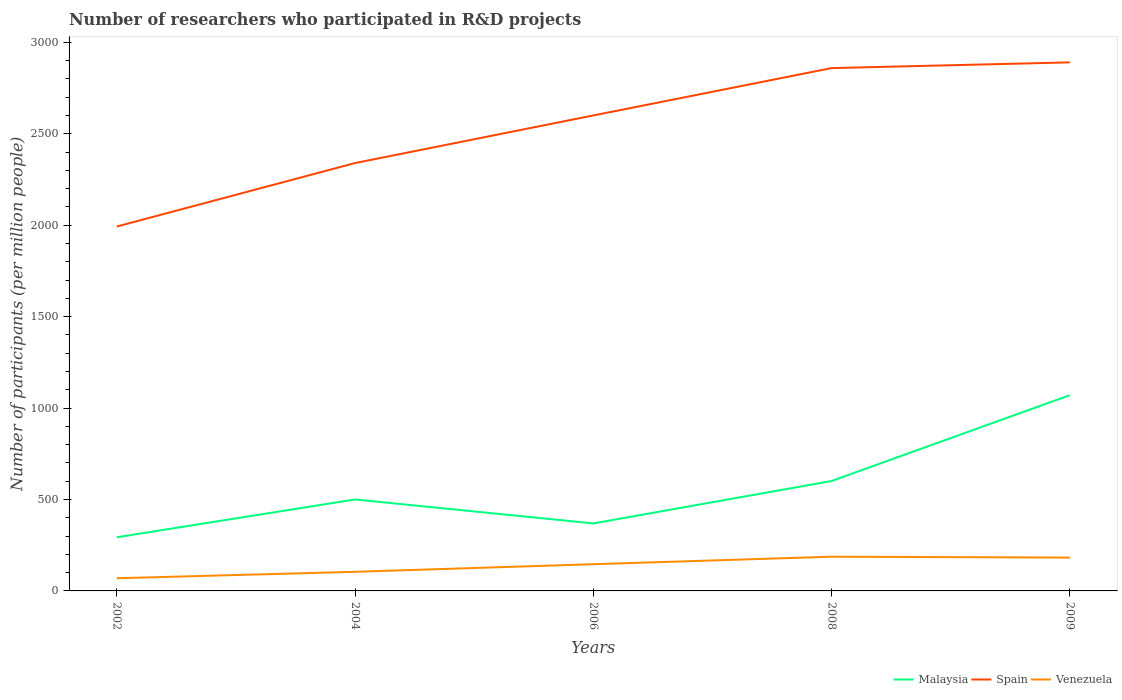Across all years, what is the maximum number of researchers who participated in R&D projects in Venezuela?
Offer a terse response. 69.33. In which year was the number of researchers who participated in R&D projects in Venezuela maximum?
Offer a terse response. 2002. What is the total number of researchers who participated in R&D projects in Malaysia in the graph?
Keep it short and to the point. -570.26. What is the difference between the highest and the second highest number of researchers who participated in R&D projects in Malaysia?
Your answer should be very brief. 777.1. What is the difference between the highest and the lowest number of researchers who participated in R&D projects in Spain?
Offer a very short reply. 3. How many years are there in the graph?
Give a very brief answer. 5. Does the graph contain grids?
Provide a short and direct response. No. How many legend labels are there?
Keep it short and to the point. 3. What is the title of the graph?
Offer a terse response. Number of researchers who participated in R&D projects. Does "Iraq" appear as one of the legend labels in the graph?
Your response must be concise. No. What is the label or title of the Y-axis?
Offer a terse response. Number of participants (per million people). What is the Number of participants (per million people) of Malaysia in 2002?
Provide a succinct answer. 293.3. What is the Number of participants (per million people) in Spain in 2002?
Your answer should be very brief. 1992.51. What is the Number of participants (per million people) in Venezuela in 2002?
Your answer should be very brief. 69.33. What is the Number of participants (per million people) of Malaysia in 2004?
Give a very brief answer. 500.14. What is the Number of participants (per million people) in Spain in 2004?
Provide a short and direct response. 2339.61. What is the Number of participants (per million people) of Venezuela in 2004?
Your answer should be compact. 104.47. What is the Number of participants (per million people) of Malaysia in 2006?
Offer a very short reply. 369.12. What is the Number of participants (per million people) of Spain in 2006?
Provide a short and direct response. 2600. What is the Number of participants (per million people) of Venezuela in 2006?
Offer a terse response. 146.1. What is the Number of participants (per million people) of Malaysia in 2008?
Keep it short and to the point. 600.96. What is the Number of participants (per million people) of Spain in 2008?
Your answer should be compact. 2858.9. What is the Number of participants (per million people) of Venezuela in 2008?
Provide a succinct answer. 187.11. What is the Number of participants (per million people) in Malaysia in 2009?
Make the answer very short. 1070.39. What is the Number of participants (per million people) of Spain in 2009?
Your answer should be compact. 2890.22. What is the Number of participants (per million people) of Venezuela in 2009?
Give a very brief answer. 182.4. Across all years, what is the maximum Number of participants (per million people) of Malaysia?
Ensure brevity in your answer.  1070.39. Across all years, what is the maximum Number of participants (per million people) of Spain?
Offer a very short reply. 2890.22. Across all years, what is the maximum Number of participants (per million people) in Venezuela?
Ensure brevity in your answer.  187.11. Across all years, what is the minimum Number of participants (per million people) of Malaysia?
Your answer should be compact. 293.3. Across all years, what is the minimum Number of participants (per million people) in Spain?
Your answer should be very brief. 1992.51. Across all years, what is the minimum Number of participants (per million people) in Venezuela?
Offer a very short reply. 69.33. What is the total Number of participants (per million people) in Malaysia in the graph?
Your answer should be very brief. 2833.91. What is the total Number of participants (per million people) in Spain in the graph?
Offer a terse response. 1.27e+04. What is the total Number of participants (per million people) of Venezuela in the graph?
Provide a short and direct response. 689.41. What is the difference between the Number of participants (per million people) of Malaysia in 2002 and that in 2004?
Offer a terse response. -206.84. What is the difference between the Number of participants (per million people) of Spain in 2002 and that in 2004?
Offer a terse response. -347.1. What is the difference between the Number of participants (per million people) in Venezuela in 2002 and that in 2004?
Give a very brief answer. -35.13. What is the difference between the Number of participants (per million people) in Malaysia in 2002 and that in 2006?
Give a very brief answer. -75.83. What is the difference between the Number of participants (per million people) in Spain in 2002 and that in 2006?
Keep it short and to the point. -607.48. What is the difference between the Number of participants (per million people) of Venezuela in 2002 and that in 2006?
Provide a short and direct response. -76.77. What is the difference between the Number of participants (per million people) of Malaysia in 2002 and that in 2008?
Provide a short and direct response. -307.66. What is the difference between the Number of participants (per million people) in Spain in 2002 and that in 2008?
Provide a short and direct response. -866.39. What is the difference between the Number of participants (per million people) of Venezuela in 2002 and that in 2008?
Provide a short and direct response. -117.78. What is the difference between the Number of participants (per million people) in Malaysia in 2002 and that in 2009?
Keep it short and to the point. -777.1. What is the difference between the Number of participants (per million people) of Spain in 2002 and that in 2009?
Offer a terse response. -897.71. What is the difference between the Number of participants (per million people) of Venezuela in 2002 and that in 2009?
Offer a very short reply. -113.06. What is the difference between the Number of participants (per million people) of Malaysia in 2004 and that in 2006?
Provide a succinct answer. 131.01. What is the difference between the Number of participants (per million people) of Spain in 2004 and that in 2006?
Ensure brevity in your answer.  -260.39. What is the difference between the Number of participants (per million people) in Venezuela in 2004 and that in 2006?
Your response must be concise. -41.63. What is the difference between the Number of participants (per million people) in Malaysia in 2004 and that in 2008?
Ensure brevity in your answer.  -100.82. What is the difference between the Number of participants (per million people) in Spain in 2004 and that in 2008?
Offer a very short reply. -519.3. What is the difference between the Number of participants (per million people) of Venezuela in 2004 and that in 2008?
Your response must be concise. -82.65. What is the difference between the Number of participants (per million people) of Malaysia in 2004 and that in 2009?
Offer a terse response. -570.26. What is the difference between the Number of participants (per million people) in Spain in 2004 and that in 2009?
Ensure brevity in your answer.  -550.62. What is the difference between the Number of participants (per million people) of Venezuela in 2004 and that in 2009?
Make the answer very short. -77.93. What is the difference between the Number of participants (per million people) in Malaysia in 2006 and that in 2008?
Give a very brief answer. -231.84. What is the difference between the Number of participants (per million people) in Spain in 2006 and that in 2008?
Provide a short and direct response. -258.91. What is the difference between the Number of participants (per million people) of Venezuela in 2006 and that in 2008?
Keep it short and to the point. -41.01. What is the difference between the Number of participants (per million people) of Malaysia in 2006 and that in 2009?
Offer a very short reply. -701.27. What is the difference between the Number of participants (per million people) of Spain in 2006 and that in 2009?
Offer a terse response. -290.23. What is the difference between the Number of participants (per million people) of Venezuela in 2006 and that in 2009?
Provide a short and direct response. -36.3. What is the difference between the Number of participants (per million people) in Malaysia in 2008 and that in 2009?
Keep it short and to the point. -469.43. What is the difference between the Number of participants (per million people) in Spain in 2008 and that in 2009?
Give a very brief answer. -31.32. What is the difference between the Number of participants (per million people) of Venezuela in 2008 and that in 2009?
Provide a succinct answer. 4.72. What is the difference between the Number of participants (per million people) in Malaysia in 2002 and the Number of participants (per million people) in Spain in 2004?
Give a very brief answer. -2046.31. What is the difference between the Number of participants (per million people) in Malaysia in 2002 and the Number of participants (per million people) in Venezuela in 2004?
Provide a succinct answer. 188.83. What is the difference between the Number of participants (per million people) in Spain in 2002 and the Number of participants (per million people) in Venezuela in 2004?
Keep it short and to the point. 1888.04. What is the difference between the Number of participants (per million people) in Malaysia in 2002 and the Number of participants (per million people) in Spain in 2006?
Your answer should be compact. -2306.7. What is the difference between the Number of participants (per million people) in Malaysia in 2002 and the Number of participants (per million people) in Venezuela in 2006?
Make the answer very short. 147.2. What is the difference between the Number of participants (per million people) of Spain in 2002 and the Number of participants (per million people) of Venezuela in 2006?
Offer a terse response. 1846.41. What is the difference between the Number of participants (per million people) in Malaysia in 2002 and the Number of participants (per million people) in Spain in 2008?
Give a very brief answer. -2565.6. What is the difference between the Number of participants (per million people) in Malaysia in 2002 and the Number of participants (per million people) in Venezuela in 2008?
Ensure brevity in your answer.  106.18. What is the difference between the Number of participants (per million people) in Spain in 2002 and the Number of participants (per million people) in Venezuela in 2008?
Keep it short and to the point. 1805.4. What is the difference between the Number of participants (per million people) of Malaysia in 2002 and the Number of participants (per million people) of Spain in 2009?
Ensure brevity in your answer.  -2596.93. What is the difference between the Number of participants (per million people) in Malaysia in 2002 and the Number of participants (per million people) in Venezuela in 2009?
Keep it short and to the point. 110.9. What is the difference between the Number of participants (per million people) of Spain in 2002 and the Number of participants (per million people) of Venezuela in 2009?
Your response must be concise. 1810.11. What is the difference between the Number of participants (per million people) of Malaysia in 2004 and the Number of participants (per million people) of Spain in 2006?
Provide a succinct answer. -2099.86. What is the difference between the Number of participants (per million people) in Malaysia in 2004 and the Number of participants (per million people) in Venezuela in 2006?
Provide a short and direct response. 354.04. What is the difference between the Number of participants (per million people) of Spain in 2004 and the Number of participants (per million people) of Venezuela in 2006?
Provide a short and direct response. 2193.51. What is the difference between the Number of participants (per million people) of Malaysia in 2004 and the Number of participants (per million people) of Spain in 2008?
Ensure brevity in your answer.  -2358.76. What is the difference between the Number of participants (per million people) of Malaysia in 2004 and the Number of participants (per million people) of Venezuela in 2008?
Offer a terse response. 313.02. What is the difference between the Number of participants (per million people) in Spain in 2004 and the Number of participants (per million people) in Venezuela in 2008?
Provide a short and direct response. 2152.49. What is the difference between the Number of participants (per million people) in Malaysia in 2004 and the Number of participants (per million people) in Spain in 2009?
Provide a succinct answer. -2390.08. What is the difference between the Number of participants (per million people) in Malaysia in 2004 and the Number of participants (per million people) in Venezuela in 2009?
Make the answer very short. 317.74. What is the difference between the Number of participants (per million people) of Spain in 2004 and the Number of participants (per million people) of Venezuela in 2009?
Ensure brevity in your answer.  2157.21. What is the difference between the Number of participants (per million people) of Malaysia in 2006 and the Number of participants (per million people) of Spain in 2008?
Give a very brief answer. -2489.78. What is the difference between the Number of participants (per million people) of Malaysia in 2006 and the Number of participants (per million people) of Venezuela in 2008?
Make the answer very short. 182.01. What is the difference between the Number of participants (per million people) in Spain in 2006 and the Number of participants (per million people) in Venezuela in 2008?
Give a very brief answer. 2412.88. What is the difference between the Number of participants (per million people) in Malaysia in 2006 and the Number of participants (per million people) in Spain in 2009?
Offer a very short reply. -2521.1. What is the difference between the Number of participants (per million people) in Malaysia in 2006 and the Number of participants (per million people) in Venezuela in 2009?
Offer a very short reply. 186.73. What is the difference between the Number of participants (per million people) of Spain in 2006 and the Number of participants (per million people) of Venezuela in 2009?
Offer a very short reply. 2417.6. What is the difference between the Number of participants (per million people) of Malaysia in 2008 and the Number of participants (per million people) of Spain in 2009?
Your response must be concise. -2289.26. What is the difference between the Number of participants (per million people) of Malaysia in 2008 and the Number of participants (per million people) of Venezuela in 2009?
Offer a very short reply. 418.56. What is the difference between the Number of participants (per million people) of Spain in 2008 and the Number of participants (per million people) of Venezuela in 2009?
Make the answer very short. 2676.5. What is the average Number of participants (per million people) of Malaysia per year?
Keep it short and to the point. 566.78. What is the average Number of participants (per million people) of Spain per year?
Offer a very short reply. 2536.25. What is the average Number of participants (per million people) in Venezuela per year?
Ensure brevity in your answer.  137.88. In the year 2002, what is the difference between the Number of participants (per million people) of Malaysia and Number of participants (per million people) of Spain?
Make the answer very short. -1699.21. In the year 2002, what is the difference between the Number of participants (per million people) of Malaysia and Number of participants (per million people) of Venezuela?
Give a very brief answer. 223.96. In the year 2002, what is the difference between the Number of participants (per million people) of Spain and Number of participants (per million people) of Venezuela?
Your answer should be very brief. 1923.18. In the year 2004, what is the difference between the Number of participants (per million people) in Malaysia and Number of participants (per million people) in Spain?
Provide a succinct answer. -1839.47. In the year 2004, what is the difference between the Number of participants (per million people) in Malaysia and Number of participants (per million people) in Venezuela?
Your response must be concise. 395.67. In the year 2004, what is the difference between the Number of participants (per million people) of Spain and Number of participants (per million people) of Venezuela?
Ensure brevity in your answer.  2235.14. In the year 2006, what is the difference between the Number of participants (per million people) in Malaysia and Number of participants (per million people) in Spain?
Offer a terse response. -2230.87. In the year 2006, what is the difference between the Number of participants (per million people) in Malaysia and Number of participants (per million people) in Venezuela?
Your answer should be compact. 223.02. In the year 2006, what is the difference between the Number of participants (per million people) in Spain and Number of participants (per million people) in Venezuela?
Provide a short and direct response. 2453.9. In the year 2008, what is the difference between the Number of participants (per million people) of Malaysia and Number of participants (per million people) of Spain?
Your answer should be compact. -2257.94. In the year 2008, what is the difference between the Number of participants (per million people) of Malaysia and Number of participants (per million people) of Venezuela?
Your answer should be very brief. 413.85. In the year 2008, what is the difference between the Number of participants (per million people) of Spain and Number of participants (per million people) of Venezuela?
Offer a very short reply. 2671.79. In the year 2009, what is the difference between the Number of participants (per million people) in Malaysia and Number of participants (per million people) in Spain?
Give a very brief answer. -1819.83. In the year 2009, what is the difference between the Number of participants (per million people) of Malaysia and Number of participants (per million people) of Venezuela?
Offer a terse response. 888. In the year 2009, what is the difference between the Number of participants (per million people) in Spain and Number of participants (per million people) in Venezuela?
Ensure brevity in your answer.  2707.83. What is the ratio of the Number of participants (per million people) in Malaysia in 2002 to that in 2004?
Keep it short and to the point. 0.59. What is the ratio of the Number of participants (per million people) in Spain in 2002 to that in 2004?
Offer a very short reply. 0.85. What is the ratio of the Number of participants (per million people) in Venezuela in 2002 to that in 2004?
Your answer should be compact. 0.66. What is the ratio of the Number of participants (per million people) in Malaysia in 2002 to that in 2006?
Your answer should be compact. 0.79. What is the ratio of the Number of participants (per million people) of Spain in 2002 to that in 2006?
Offer a very short reply. 0.77. What is the ratio of the Number of participants (per million people) of Venezuela in 2002 to that in 2006?
Keep it short and to the point. 0.47. What is the ratio of the Number of participants (per million people) of Malaysia in 2002 to that in 2008?
Offer a terse response. 0.49. What is the ratio of the Number of participants (per million people) in Spain in 2002 to that in 2008?
Offer a terse response. 0.7. What is the ratio of the Number of participants (per million people) of Venezuela in 2002 to that in 2008?
Make the answer very short. 0.37. What is the ratio of the Number of participants (per million people) of Malaysia in 2002 to that in 2009?
Keep it short and to the point. 0.27. What is the ratio of the Number of participants (per million people) of Spain in 2002 to that in 2009?
Give a very brief answer. 0.69. What is the ratio of the Number of participants (per million people) of Venezuela in 2002 to that in 2009?
Provide a succinct answer. 0.38. What is the ratio of the Number of participants (per million people) in Malaysia in 2004 to that in 2006?
Provide a succinct answer. 1.35. What is the ratio of the Number of participants (per million people) of Spain in 2004 to that in 2006?
Give a very brief answer. 0.9. What is the ratio of the Number of participants (per million people) of Venezuela in 2004 to that in 2006?
Make the answer very short. 0.71. What is the ratio of the Number of participants (per million people) in Malaysia in 2004 to that in 2008?
Provide a succinct answer. 0.83. What is the ratio of the Number of participants (per million people) in Spain in 2004 to that in 2008?
Your response must be concise. 0.82. What is the ratio of the Number of participants (per million people) in Venezuela in 2004 to that in 2008?
Ensure brevity in your answer.  0.56. What is the ratio of the Number of participants (per million people) in Malaysia in 2004 to that in 2009?
Ensure brevity in your answer.  0.47. What is the ratio of the Number of participants (per million people) of Spain in 2004 to that in 2009?
Provide a short and direct response. 0.81. What is the ratio of the Number of participants (per million people) in Venezuela in 2004 to that in 2009?
Provide a succinct answer. 0.57. What is the ratio of the Number of participants (per million people) in Malaysia in 2006 to that in 2008?
Give a very brief answer. 0.61. What is the ratio of the Number of participants (per million people) of Spain in 2006 to that in 2008?
Ensure brevity in your answer.  0.91. What is the ratio of the Number of participants (per million people) of Venezuela in 2006 to that in 2008?
Your answer should be very brief. 0.78. What is the ratio of the Number of participants (per million people) of Malaysia in 2006 to that in 2009?
Ensure brevity in your answer.  0.34. What is the ratio of the Number of participants (per million people) in Spain in 2006 to that in 2009?
Your response must be concise. 0.9. What is the ratio of the Number of participants (per million people) of Venezuela in 2006 to that in 2009?
Offer a terse response. 0.8. What is the ratio of the Number of participants (per million people) of Malaysia in 2008 to that in 2009?
Your response must be concise. 0.56. What is the ratio of the Number of participants (per million people) of Venezuela in 2008 to that in 2009?
Provide a short and direct response. 1.03. What is the difference between the highest and the second highest Number of participants (per million people) in Malaysia?
Keep it short and to the point. 469.43. What is the difference between the highest and the second highest Number of participants (per million people) in Spain?
Provide a succinct answer. 31.32. What is the difference between the highest and the second highest Number of participants (per million people) in Venezuela?
Your response must be concise. 4.72. What is the difference between the highest and the lowest Number of participants (per million people) of Malaysia?
Your answer should be very brief. 777.1. What is the difference between the highest and the lowest Number of participants (per million people) in Spain?
Your answer should be compact. 897.71. What is the difference between the highest and the lowest Number of participants (per million people) of Venezuela?
Keep it short and to the point. 117.78. 